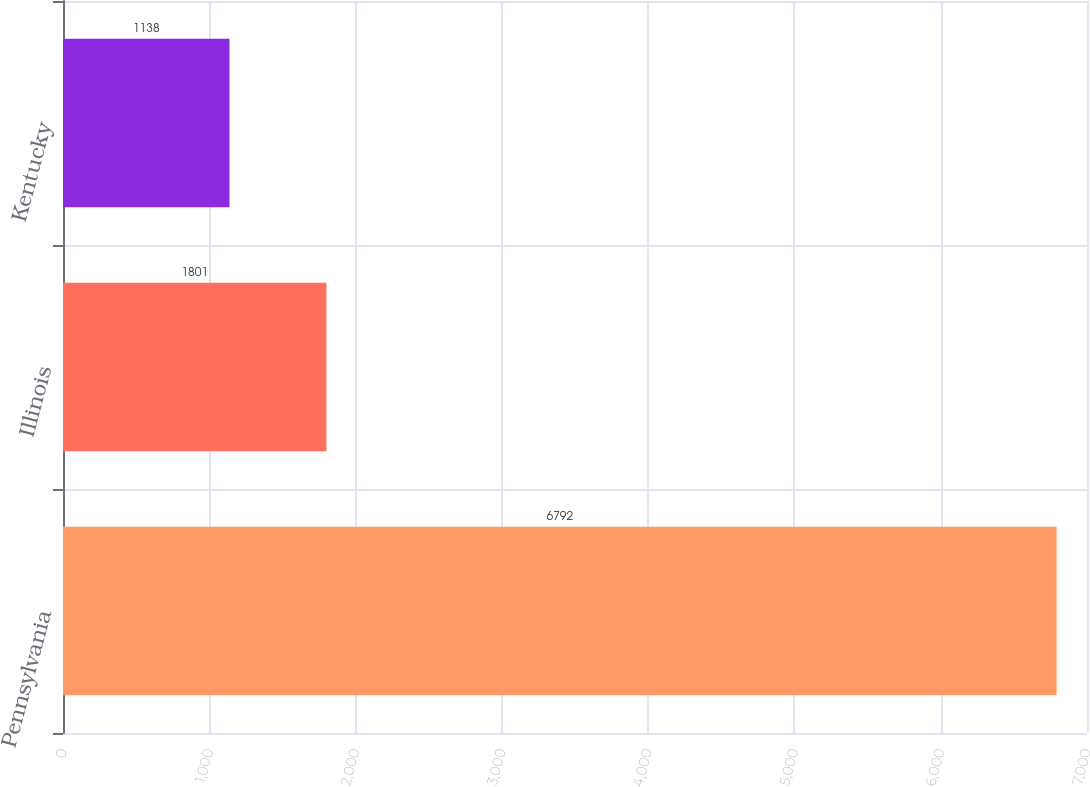Convert chart. <chart><loc_0><loc_0><loc_500><loc_500><bar_chart><fcel>Pennsylvania<fcel>Illinois<fcel>Kentucky<nl><fcel>6792<fcel>1801<fcel>1138<nl></chart> 